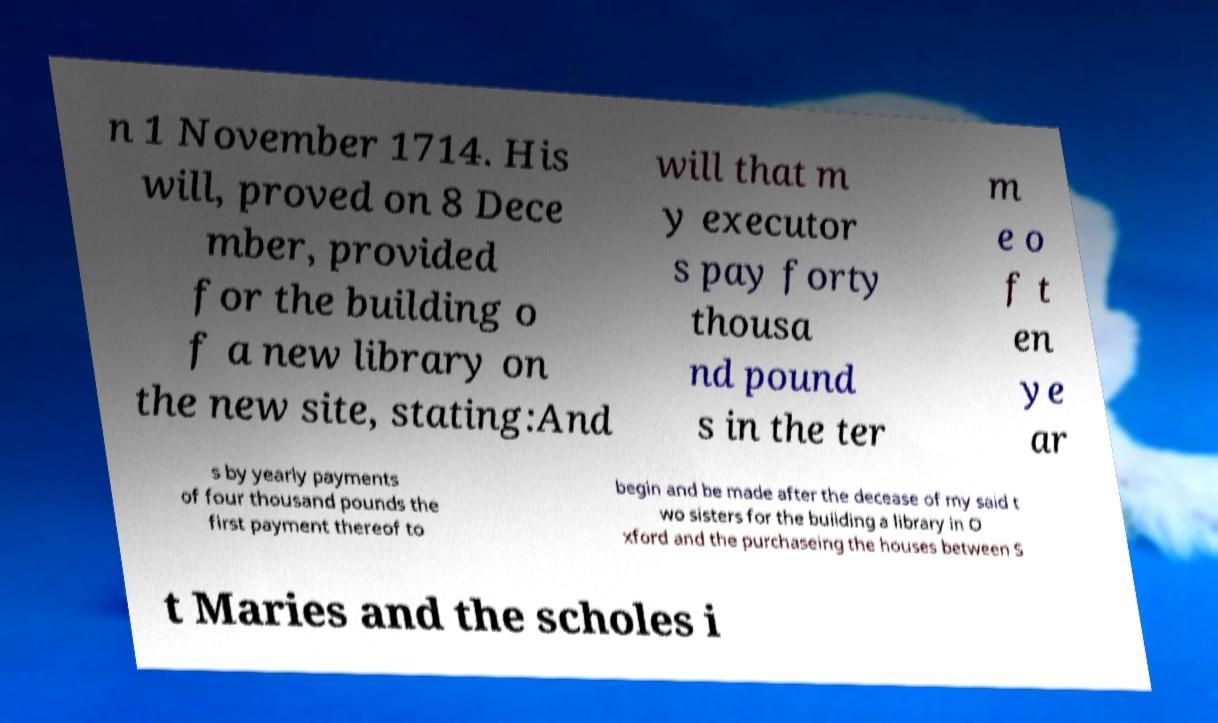Please read and relay the text visible in this image. What does it say? n 1 November 1714. His will, proved on 8 Dece mber, provided for the building o f a new library on the new site, stating:And will that m y executor s pay forty thousa nd pound s in the ter m e o f t en ye ar s by yearly payments of four thousand pounds the first payment thereof to begin and be made after the decease of my said t wo sisters for the building a library in O xford and the purchaseing the houses between S t Maries and the scholes i 